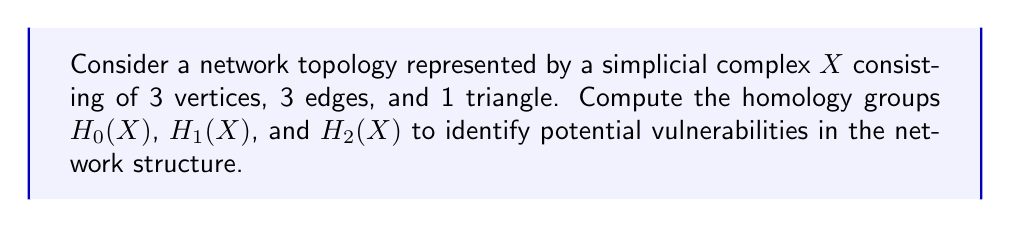What is the answer to this math problem? To compute the homology groups of the given topological space, we'll follow these steps:

1) First, let's define the chain groups:
   $C_0(X)$ is generated by 3 vertices: $\{v_1, v_2, v_3\}$
   $C_1(X)$ is generated by 3 edges: $\{e_1, e_2, e_3\}$
   $C_2(X)$ is generated by 1 triangle: $\{t\}$

2) Now, we need to define the boundary maps:
   $\partial_2: C_2(X) \to C_1(X)$
   $\partial_1: C_1(X) \to C_0(X)$

3) Let's calculate the kernels and images of these maps:
   $\ker(\partial_1) = \{c \in C_1(X) | \partial_1(c) = 0\}$
   $\text{im}(\partial_2) = \{\partial_2(c) | c \in C_2(X)\}$

4) For $H_0(X)$:
   $H_0(X) = \ker(\partial_0) / \text{im}(\partial_1)$
   Since $\partial_0$ is the zero map, $\ker(\partial_0) = C_0(X)$
   $\text{im}(\partial_1)$ is generated by differences of vertices
   Thus, $H_0(X) \cong \mathbb{Z}$, indicating one connected component

5) For $H_1(X)$:
   $H_1(X) = \ker(\partial_1) / \text{im}(\partial_2)$
   $\ker(\partial_1)$ consists of cycles in $X$
   $\text{im}(\partial_2)$ is the boundary of the triangle
   Since the triangle fills the only cycle, $H_1(X) \cong 0$

6) For $H_2(X)$:
   $H_2(X) = \ker(\partial_2) / \text{im}(\partial_3)$
   Since there are no 3-simplices, $\text{im}(\partial_3) = 0$
   $\ker(\partial_2)$ is generated by the triangle
   Thus, $H_2(X) \cong \mathbb{Z}$

From a cybersecurity perspective:
- $H_0(X) \cong \mathbb{Z}$ indicates a single connected network, with no isolated components.
- $H_1(X) \cong 0$ suggests no cycles or loops in the network topology that aren't filled, potentially limiting redundant paths for data flow.
- $H_2(X) \cong \mathbb{Z}$ represents a fully enclosed 2-dimensional structure, which could indicate a tightly interconnected subnet.
Answer: $H_0(X) \cong \mathbb{Z}$, $H_1(X) \cong 0$, $H_2(X) \cong \mathbb{Z}$ 